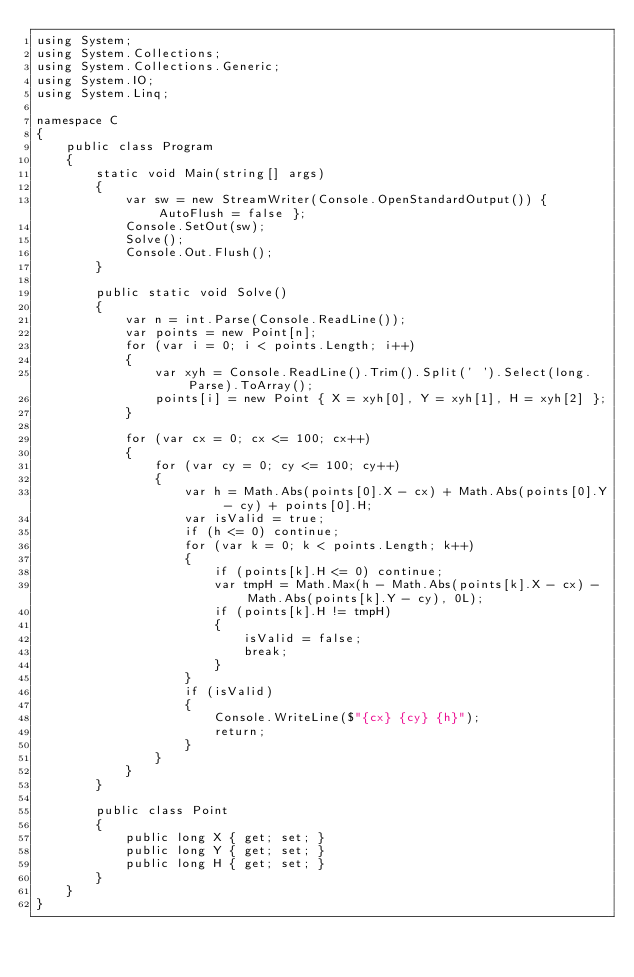<code> <loc_0><loc_0><loc_500><loc_500><_C#_>using System;
using System.Collections;
using System.Collections.Generic;
using System.IO;
using System.Linq;

namespace C
{
    public class Program
    {
        static void Main(string[] args)
        {
            var sw = new StreamWriter(Console.OpenStandardOutput()) { AutoFlush = false };
            Console.SetOut(sw);
            Solve();
            Console.Out.Flush();
        }

        public static void Solve()
        {
            var n = int.Parse(Console.ReadLine());
            var points = new Point[n];
            for (var i = 0; i < points.Length; i++)
            {
                var xyh = Console.ReadLine().Trim().Split(' ').Select(long.Parse).ToArray();
                points[i] = new Point { X = xyh[0], Y = xyh[1], H = xyh[2] };
            }

            for (var cx = 0; cx <= 100; cx++)
            {
                for (var cy = 0; cy <= 100; cy++)
                {
                    var h = Math.Abs(points[0].X - cx) + Math.Abs(points[0].Y - cy) + points[0].H;
                    var isValid = true;
                    if (h <= 0) continue;
                    for (var k = 0; k < points.Length; k++)
                    {
                        if (points[k].H <= 0) continue;
                        var tmpH = Math.Max(h - Math.Abs(points[k].X - cx) - Math.Abs(points[k].Y - cy), 0L);
                        if (points[k].H != tmpH)
                        {
                            isValid = false;
                            break;
                        }
                    }
                    if (isValid)
                    {
                        Console.WriteLine($"{cx} {cy} {h}");
                        return;
                    }
                }
            }
        }

        public class Point
        {
            public long X { get; set; }
            public long Y { get; set; }
            public long H { get; set; }
        }
    }
}
</code> 